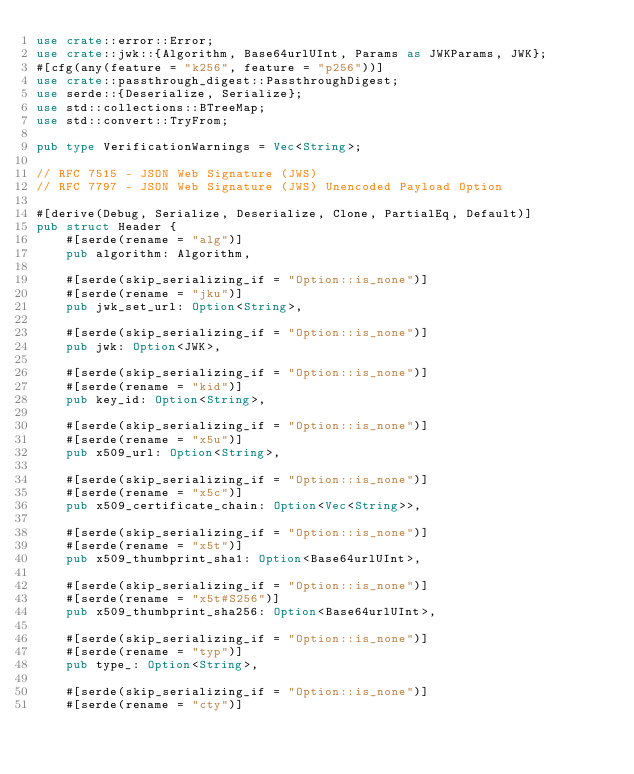Convert code to text. <code><loc_0><loc_0><loc_500><loc_500><_Rust_>use crate::error::Error;
use crate::jwk::{Algorithm, Base64urlUInt, Params as JWKParams, JWK};
#[cfg(any(feature = "k256", feature = "p256"))]
use crate::passthrough_digest::PassthroughDigest;
use serde::{Deserialize, Serialize};
use std::collections::BTreeMap;
use std::convert::TryFrom;

pub type VerificationWarnings = Vec<String>;

// RFC 7515 - JSON Web Signature (JWS)
// RFC 7797 - JSON Web Signature (JWS) Unencoded Payload Option

#[derive(Debug, Serialize, Deserialize, Clone, PartialEq, Default)]
pub struct Header {
    #[serde(rename = "alg")]
    pub algorithm: Algorithm,

    #[serde(skip_serializing_if = "Option::is_none")]
    #[serde(rename = "jku")]
    pub jwk_set_url: Option<String>,

    #[serde(skip_serializing_if = "Option::is_none")]
    pub jwk: Option<JWK>,

    #[serde(skip_serializing_if = "Option::is_none")]
    #[serde(rename = "kid")]
    pub key_id: Option<String>,

    #[serde(skip_serializing_if = "Option::is_none")]
    #[serde(rename = "x5u")]
    pub x509_url: Option<String>,

    #[serde(skip_serializing_if = "Option::is_none")]
    #[serde(rename = "x5c")]
    pub x509_certificate_chain: Option<Vec<String>>,

    #[serde(skip_serializing_if = "Option::is_none")]
    #[serde(rename = "x5t")]
    pub x509_thumbprint_sha1: Option<Base64urlUInt>,

    #[serde(skip_serializing_if = "Option::is_none")]
    #[serde(rename = "x5t#S256")]
    pub x509_thumbprint_sha256: Option<Base64urlUInt>,

    #[serde(skip_serializing_if = "Option::is_none")]
    #[serde(rename = "typ")]
    pub type_: Option<String>,

    #[serde(skip_serializing_if = "Option::is_none")]
    #[serde(rename = "cty")]</code> 